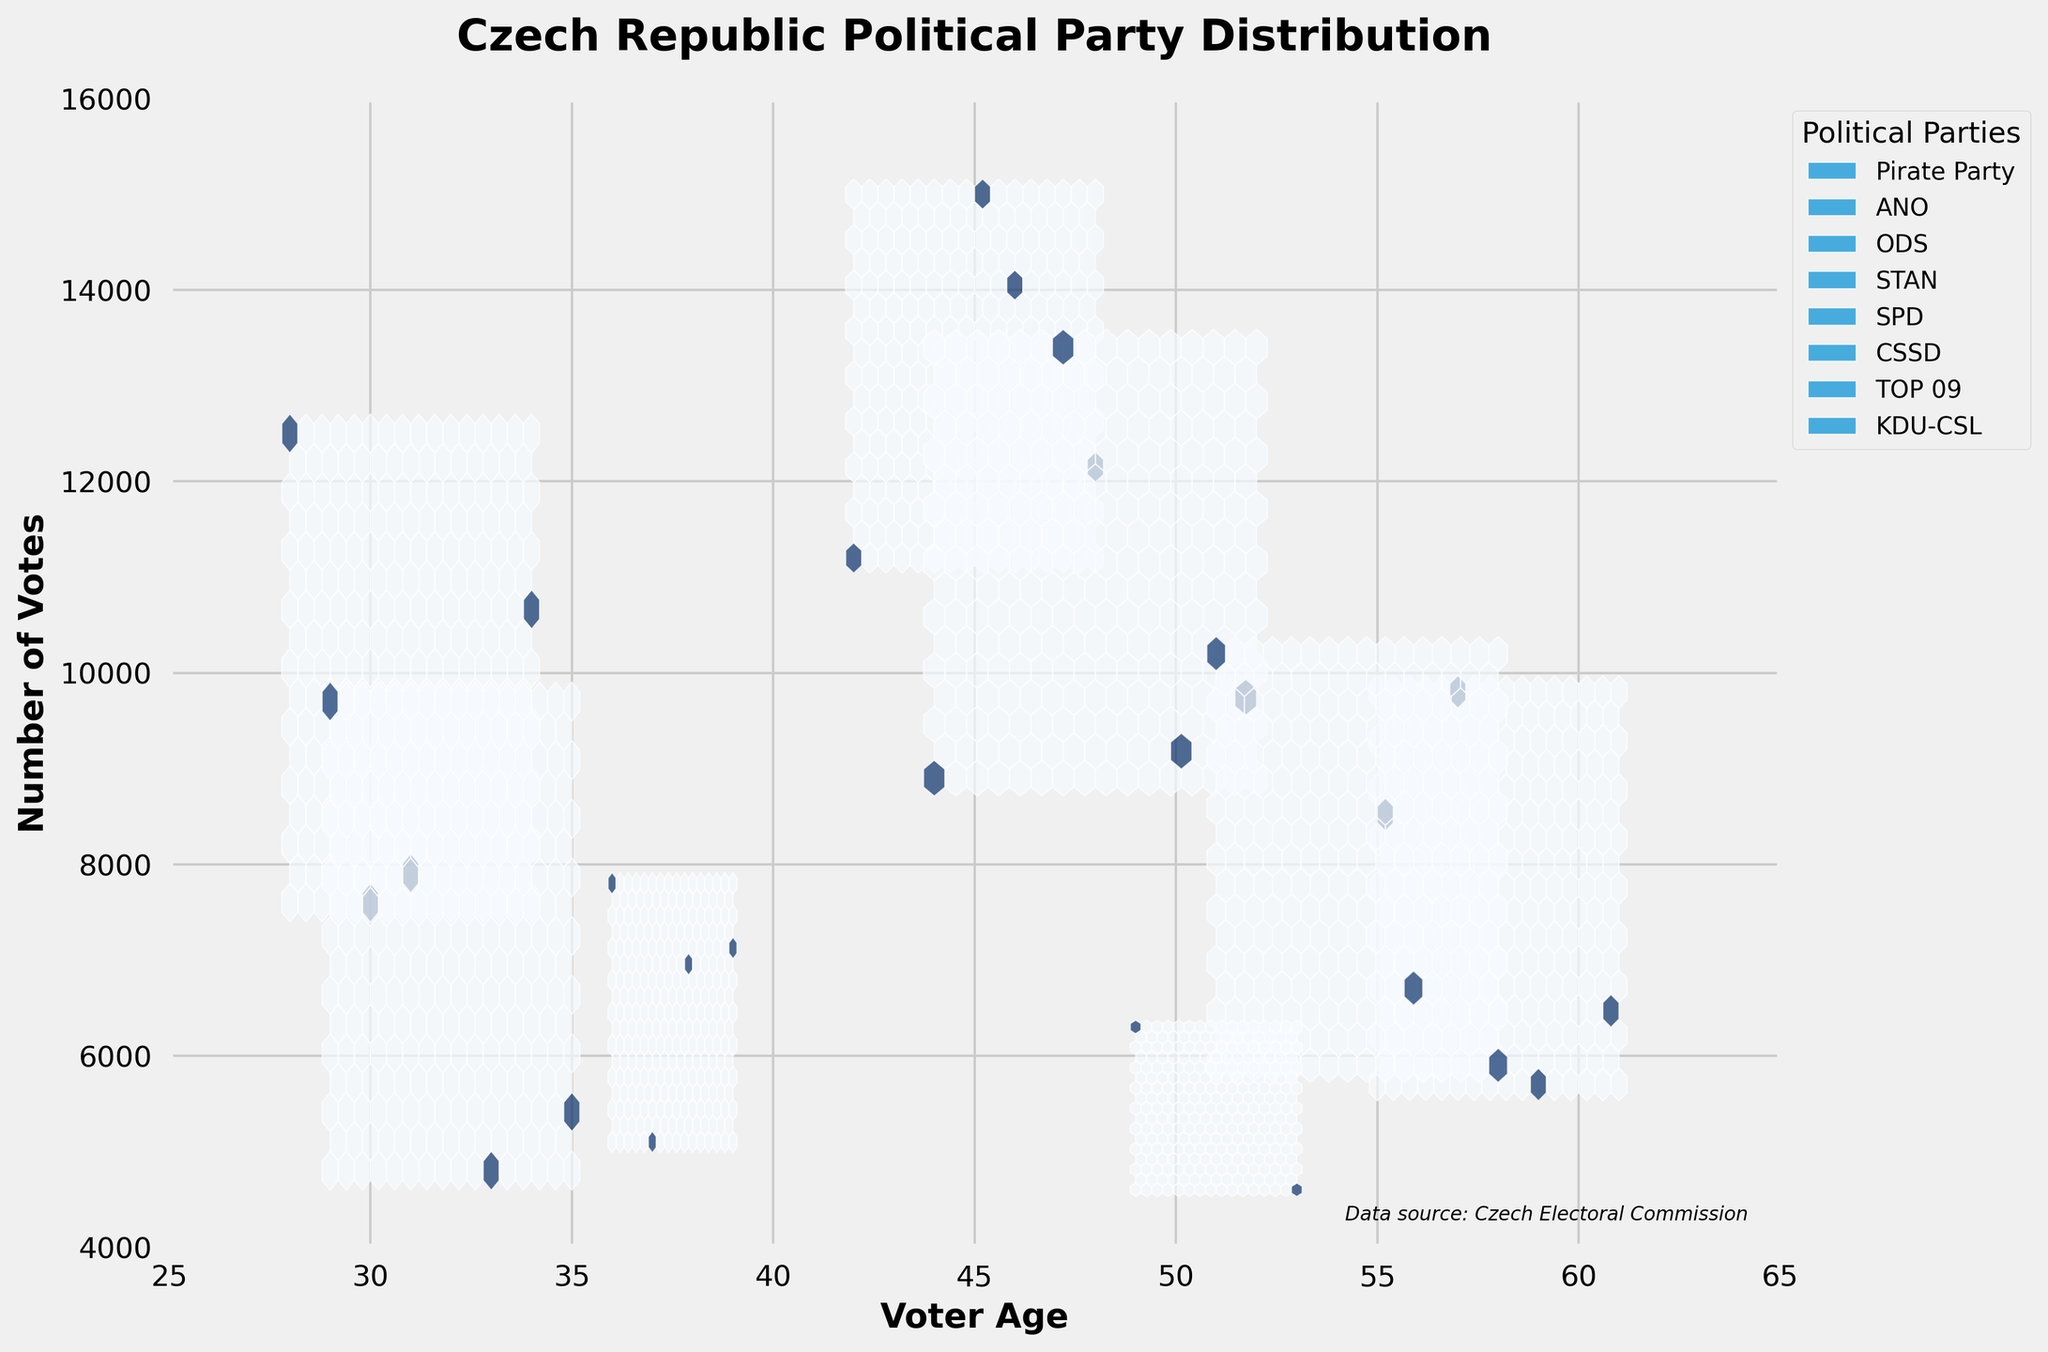How many distinct political parties are represented in the figure? By looking at the legend on the figure, you can count the unique political parties listed.
Answer: 7 What title is given to the figure? The title of the figure is clearly stated at the top of the plot.
Answer: Czech Republic Political Party Distribution Which axis represents 'Voter Age'? The label under the horizontal axis indicates it represents 'Voter Age'.
Answer: x-axis What is the approximate age range of voters for the Pirate Party in Prague? For this question, locate the hex points for the Pirate Party under Prague and observe the horizontal range.
Answer: Approximately 28 - 31 Which political party has the highest concentration of votes around the age 45? Identify the hexbin with the darkest shade around the age 45 and match it to the party indicated by the legend.
Answer: ANO What is the age group with the highest number of votes for ODS? ODS (indicated in the legend) has most of its hexagons at the darkest shade clustered around certain ages on the x-axis.
Answer: Around 47-50 How does the voter distribution of the Pirate Party compare between Prague and Pardubice? Locate the hexagons for the Pirate Party in Prague and Pardubice and compare the density and number of votes as represented by the color shading and number of hexagons.
Answer: More votes and a wider age range in Prague compared to Pardubice Which age group has the highest number of votes for STAN in Plzen? Check the hexagons for STAN in the Plzen region and see which age groups contain the darkest hexagons.
Answer: Around 36-39 How do the distributions of votes for ANO and ODS compare in South Bohemia? Look at the hexagons for ANO and ODS in South Bohemia, overlaying the colors and concentrations can help compare the distributions.
Answer: ANO has a slightly wider age range and higher concentration around mid-40s, while ODS peaks around early 50s What's the range of the number of votes observed in the plot? The y-axis limits give the range of the number of votes in the figure.
Answer: 4000 - 16000 